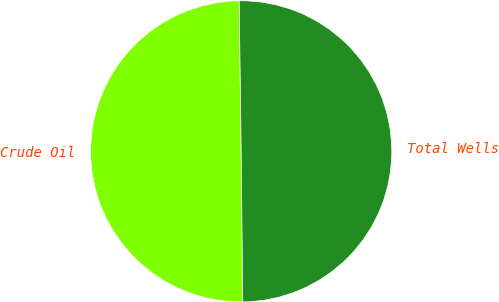<chart> <loc_0><loc_0><loc_500><loc_500><pie_chart><fcel>Crude Oil<fcel>Total Wells<nl><fcel>49.96%<fcel>50.04%<nl></chart> 